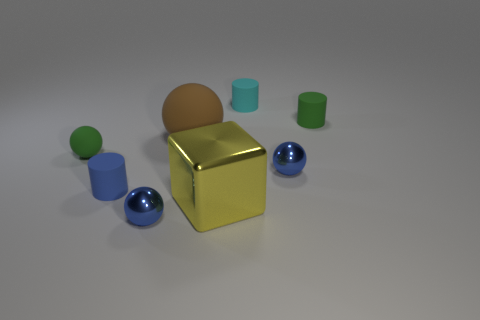How big is the yellow object that is to the left of the tiny cyan rubber object? The yellow object to the left of the tiny cyan object is relatively large in comparison. It's a cube with a reflective surface, taking up substantial space in the image. 